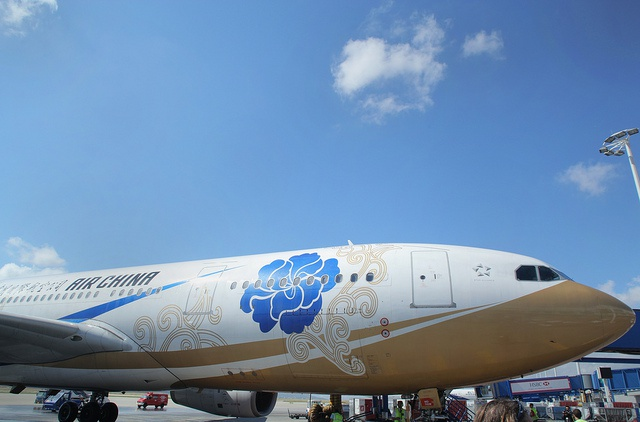Describe the objects in this image and their specific colors. I can see airplane in lightblue, lightgray, black, and gray tones, people in lightblue, black, and gray tones, truck in lightblue, maroon, black, gray, and darkgray tones, people in lightblue, black, darkgreen, and gray tones, and people in lightblue, black, gray, purple, and darkblue tones in this image. 